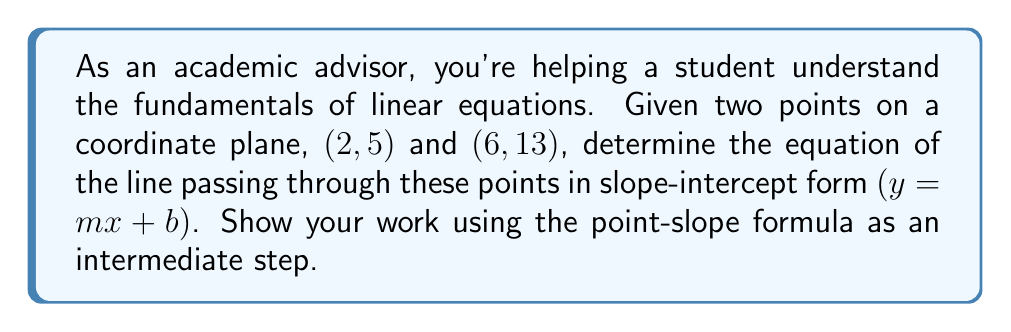What is the answer to this math problem? Let's approach this step-by-step using well-established methods:

1) First, we need to calculate the slope $(m)$ using the slope formula:
   $$m = \frac{y_2 - y_1}{x_2 - x_1} = \frac{13 - 5}{6 - 2} = \frac{8}{4} = 2$$

2) Now that we have the slope, we can use the point-slope form of a line:
   $$y - y_1 = m(x - x_1)$$

   Let's use the point $(2, 5)$:
   $$y - 5 = 2(x - 2)$$

3) To convert this to slope-intercept form $(y = mx + b)$, we need to distribute the 2:
   $$y - 5 = 2x - 4$$

4) Now, add 5 to both sides:
   $$y = 2x - 4 + 5$$
   $$y = 2x + 1$$

5) This is now in slope-intercept form, where $m = 2$ and $b = 1$.

6) We can verify this equation using the second point $(6, 13)$:
   $$13 \stackrel{?}{=} 2(6) + 1$$
   $$13 = 12 + 1 = 13$$
   
   The equation checks out.
Answer: $y = 2x + 1$ 